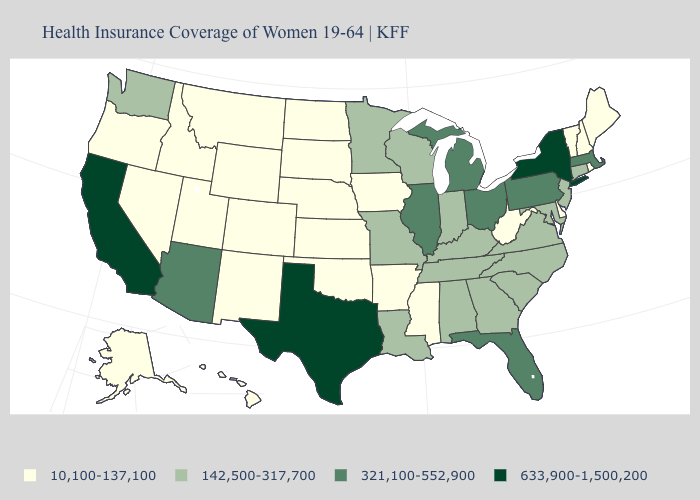What is the lowest value in the USA?
Keep it brief. 10,100-137,100. What is the lowest value in the USA?
Answer briefly. 10,100-137,100. Which states have the lowest value in the USA?
Give a very brief answer. Alaska, Arkansas, Colorado, Delaware, Hawaii, Idaho, Iowa, Kansas, Maine, Mississippi, Montana, Nebraska, Nevada, New Hampshire, New Mexico, North Dakota, Oklahoma, Oregon, Rhode Island, South Dakota, Utah, Vermont, West Virginia, Wyoming. Name the states that have a value in the range 142,500-317,700?
Give a very brief answer. Alabama, Connecticut, Georgia, Indiana, Kentucky, Louisiana, Maryland, Minnesota, Missouri, New Jersey, North Carolina, South Carolina, Tennessee, Virginia, Washington, Wisconsin. What is the lowest value in states that border Pennsylvania?
Short answer required. 10,100-137,100. Does New Mexico have a lower value than Minnesota?
Short answer required. Yes. What is the value of Wyoming?
Give a very brief answer. 10,100-137,100. Which states have the highest value in the USA?
Be succinct. California, New York, Texas. Name the states that have a value in the range 321,100-552,900?
Concise answer only. Arizona, Florida, Illinois, Massachusetts, Michigan, Ohio, Pennsylvania. Does the map have missing data?
Quick response, please. No. Does Massachusetts have the lowest value in the USA?
Quick response, please. No. Does Texas have the same value as New York?
Give a very brief answer. Yes. What is the lowest value in states that border New Mexico?
Write a very short answer. 10,100-137,100. Name the states that have a value in the range 10,100-137,100?
Quick response, please. Alaska, Arkansas, Colorado, Delaware, Hawaii, Idaho, Iowa, Kansas, Maine, Mississippi, Montana, Nebraska, Nevada, New Hampshire, New Mexico, North Dakota, Oklahoma, Oregon, Rhode Island, South Dakota, Utah, Vermont, West Virginia, Wyoming. Does the first symbol in the legend represent the smallest category?
Be succinct. Yes. 